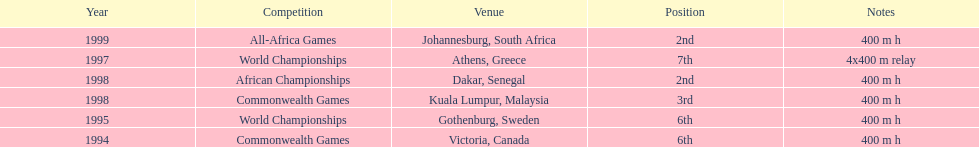Which year had the most competitions? 1998. 